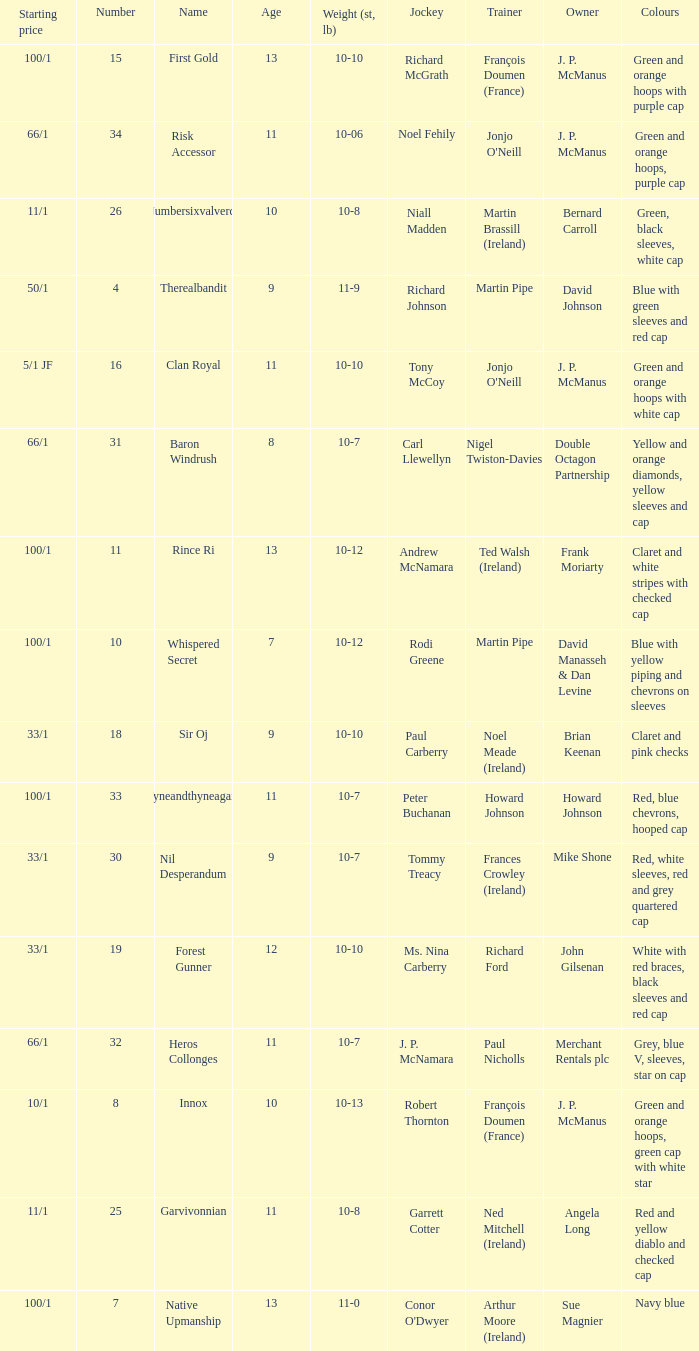How many age entries had a weight of 10-7 and an owner of Double Octagon Partnership? 1.0. 